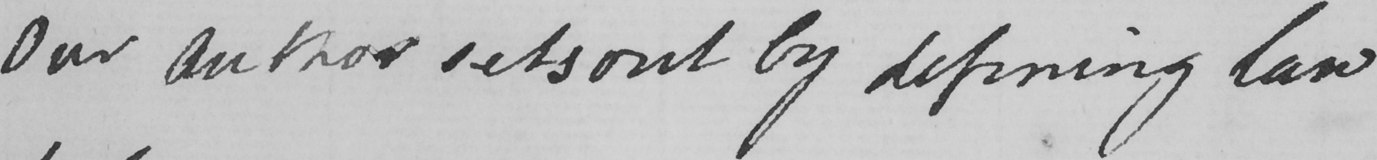Please transcribe the handwritten text in this image. Our author sets out by defining law 